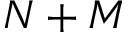<formula> <loc_0><loc_0><loc_500><loc_500>N + M</formula> 